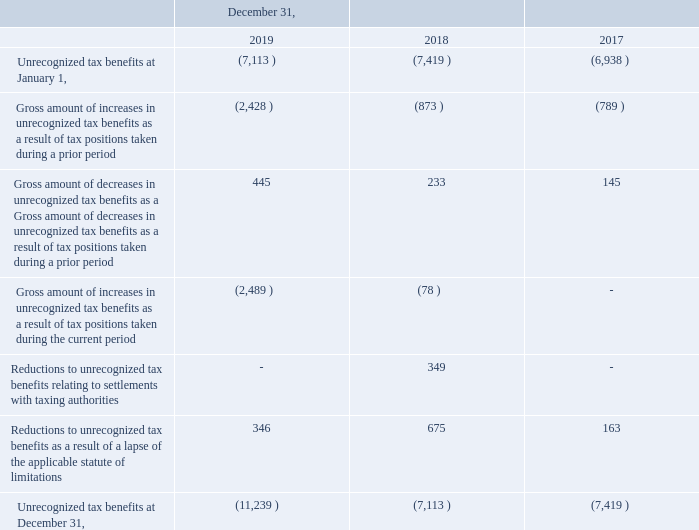A reconciliation of the beginning and ending amount of unrecognized tax benefits is as follows for the years ended December 31,
2019, 2018 and 2017 (in thousands):
Our unrecognized tax benefits totaled $11.2 million and $7.1 million as of December 31, 2019 and 2018, respectively. Included in these amounts are unrecognized tax benefits totaling $10.2 million and $5.4 million as of December 31, 2019 and 2018, respectively, which, if recognized, would affect the effective tax rate.
these amounts are unrecognized tax benefits totaling $10.2 million and $5.4 million as of December 31, 2019 and 2018, respectively,
which, if recognized, would affect the effective tax rate.
We recognize potential accrued interest and penalties related to unrecognized tax benefits within our global operations in income tax expense. For the years ended December 31, 2019, 2018 and 2017, the Company recognized the following income tax expense: $0.5 million, $0.5 million, and $0.3 million, respectively, for the potential payment of interest and penalties. Accrued interest and penalties were $1.7 million and $2.1 million for the years ended December 31, 2019 and 2018. We conduct business globally and, as a result, files income tax returns in the United State federal jurisdiction and in many state and foreign jurisdictions. We are generally no longer subject to U.S. federal, state, and local, or non-US income tax examinations for the years before 2012. Due to the expiration of statutes of limitations in multiple jurisdictions globally during 2020, the Company anticipates it is reasonably possible that unrecognized tax benefits may decrease by $3.1 million.
What is the unrecognised tax benefits as of December 31, 2019?
Answer scale should be: million. 11.2. What is the reason for unrecognised tax benefits decreasing by 3.1 million in 2020? Due to the expiration of statutes of limitations in multiple jurisdictions globally. What is the recognised income tax expense in 2017?
Answer scale should be: million. 0.3. What is the change in unrecognised tax benefits between December 31, 2019 and 2018?
Answer scale should be: thousand. 11,239-7,113
Answer: 4126. What is the change in unrecognized tax benefits between the start and end of 2017?
Answer scale should be: thousand. 7,419-6,938
Answer: 481. What is the change in unrecognised tax benefits between 2019 and 2017 year end?
Answer scale should be: thousand. 11,239-7,419
Answer: 3820. 